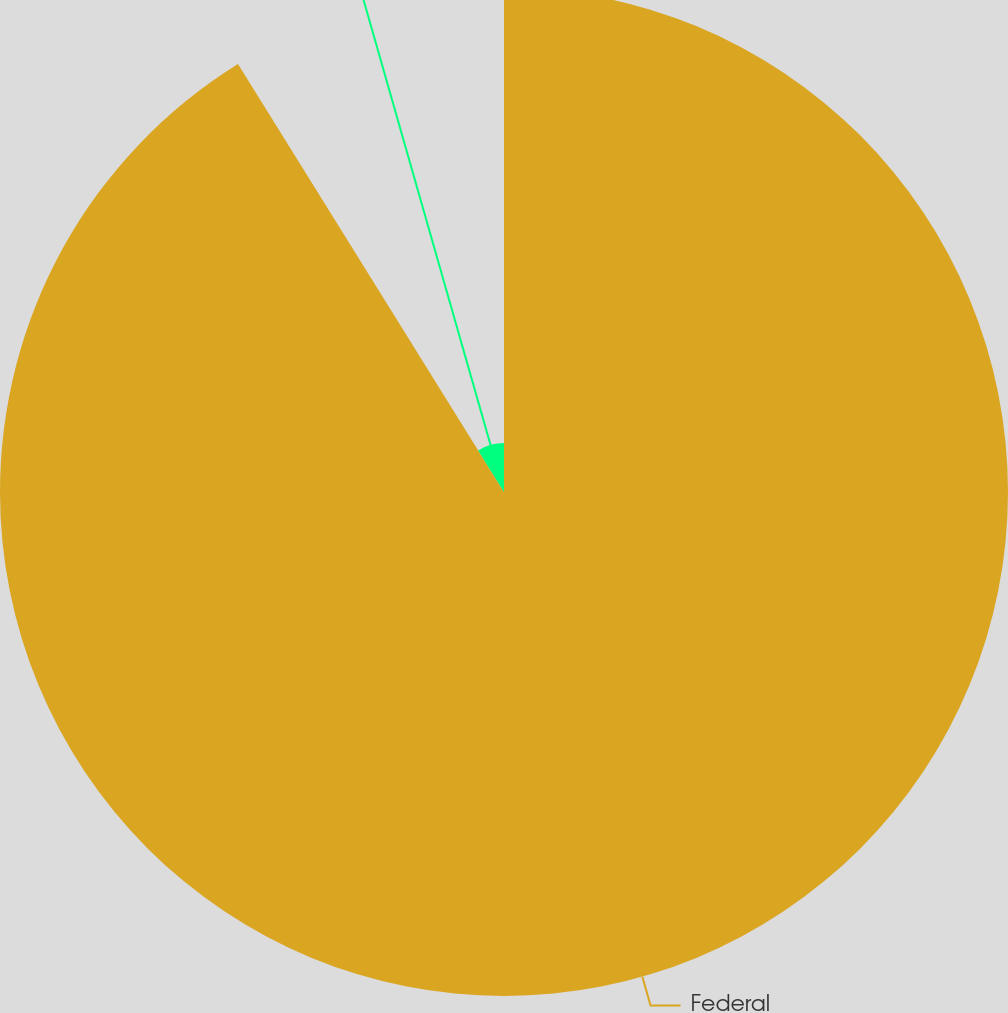Convert chart to OTSL. <chart><loc_0><loc_0><loc_500><loc_500><pie_chart><fcel>Federal<fcel>State<nl><fcel>91.15%<fcel>8.85%<nl></chart> 